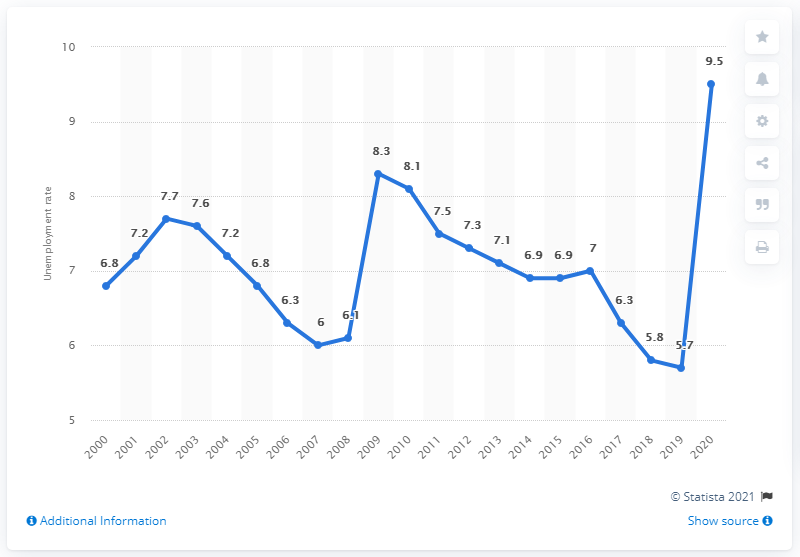Identify some key points in this picture. The unemployment rate in the previous year was 5.7%. In 2020, approximately 9.5% of the Canadian labor force was unemployed. 